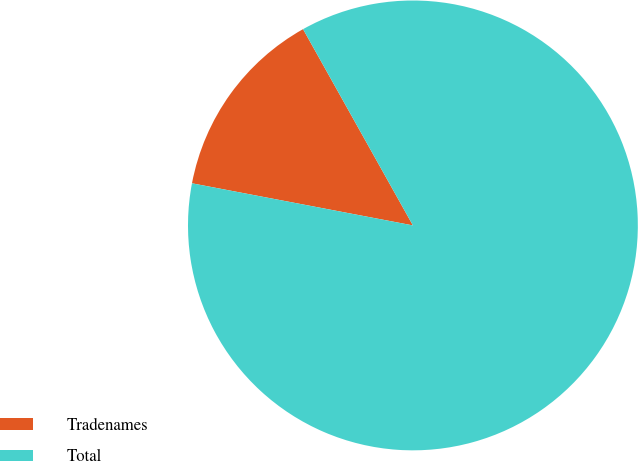Convert chart to OTSL. <chart><loc_0><loc_0><loc_500><loc_500><pie_chart><fcel>Tradenames<fcel>Total<nl><fcel>13.88%<fcel>86.12%<nl></chart> 